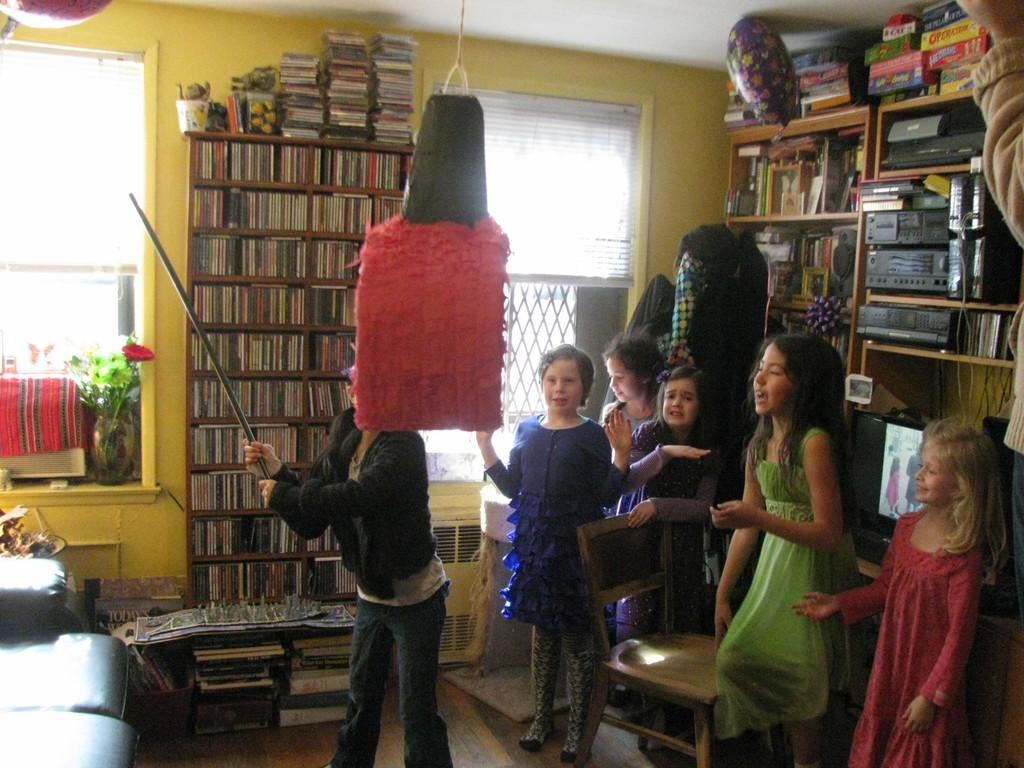What type of people can be seen in the room? There are children in the room. What is the person holding in the image? The person is holding a stick. Where can natural light enter the room? There are windows in the wall. What type of items can be found on shelves in the room? There are books on shelves in the room. What does the room smell like in the image? The image does not provide information about the smell in the room, so it cannot be determined. 